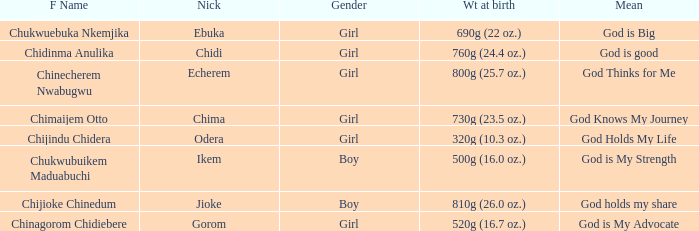How much did the girl, nicknamed Chidi, weigh at birth? 760g (24.4 oz.). 